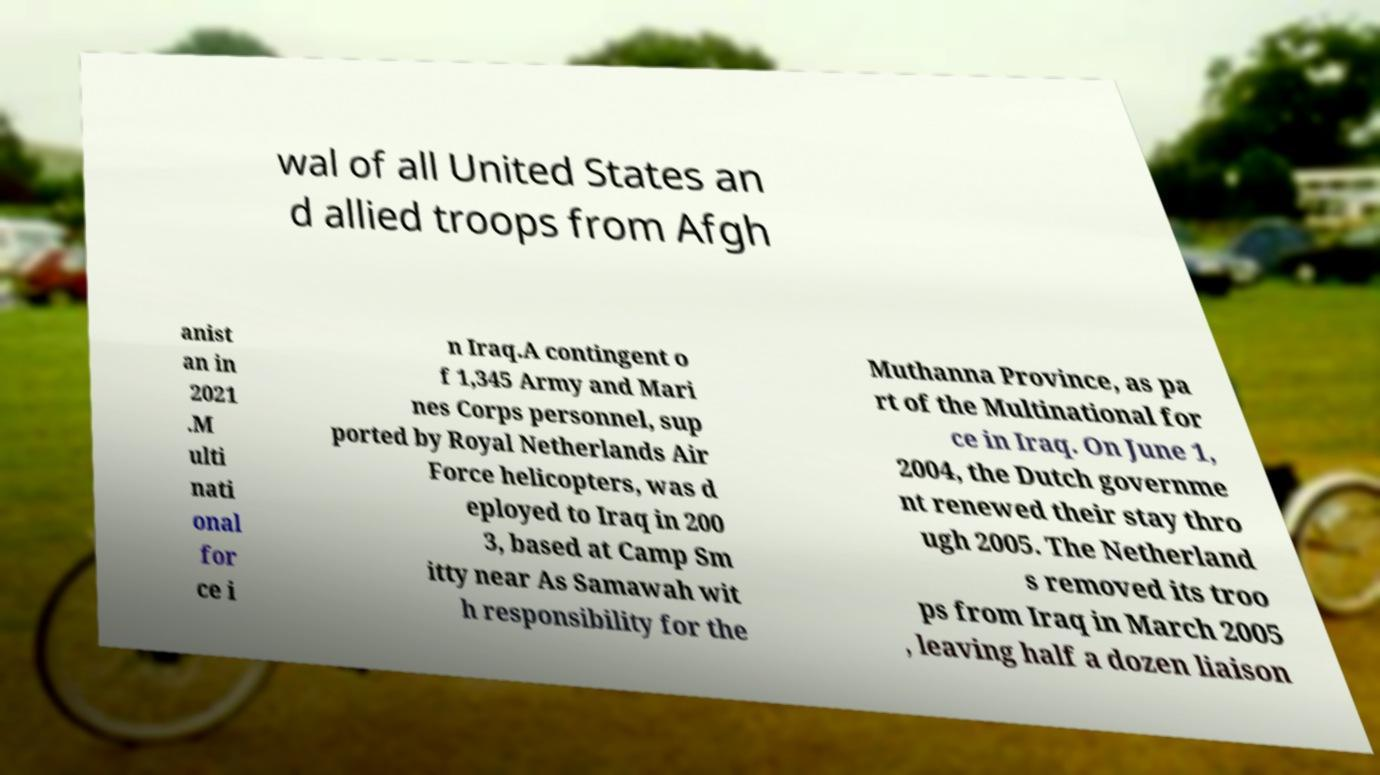Could you extract and type out the text from this image? wal of all United States an d allied troops from Afgh anist an in 2021 .M ulti nati onal for ce i n Iraq.A contingent o f 1,345 Army and Mari nes Corps personnel, sup ported by Royal Netherlands Air Force helicopters, was d eployed to Iraq in 200 3, based at Camp Sm itty near As Samawah wit h responsibility for the Muthanna Province, as pa rt of the Multinational for ce in Iraq. On June 1, 2004, the Dutch governme nt renewed their stay thro ugh 2005. The Netherland s removed its troo ps from Iraq in March 2005 , leaving half a dozen liaison 